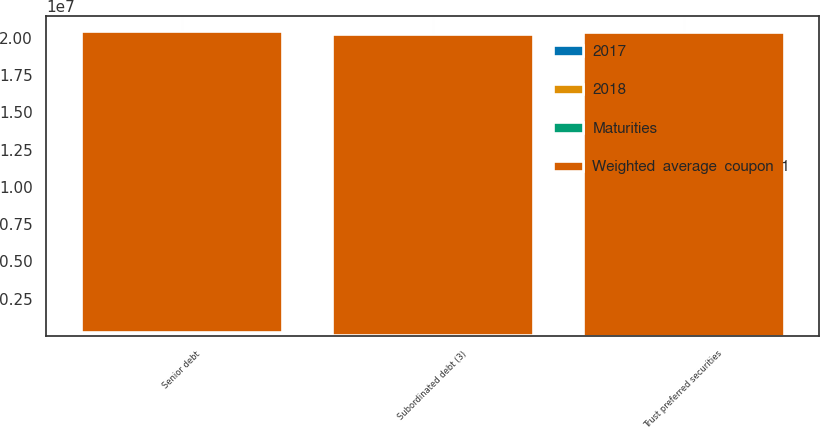Convert chart to OTSL. <chart><loc_0><loc_0><loc_500><loc_500><stacked_bar_chart><ecel><fcel>Senior debt<fcel>Subordinated debt (3)<fcel>Trust preferred securities<nl><fcel>2017<fcel>3.4<fcel>4.7<fcel>8.44<nl><fcel>Weighted  average  coupon  1<fcel>2.01921e+07<fcel>2.0192e+07<fcel>2.03621e+07<nl><fcel>2018<fcel>117511<fcel>24545<fcel>1711<nl><fcel>Maturities<fcel>123488<fcel>26963<fcel>1712<nl></chart> 